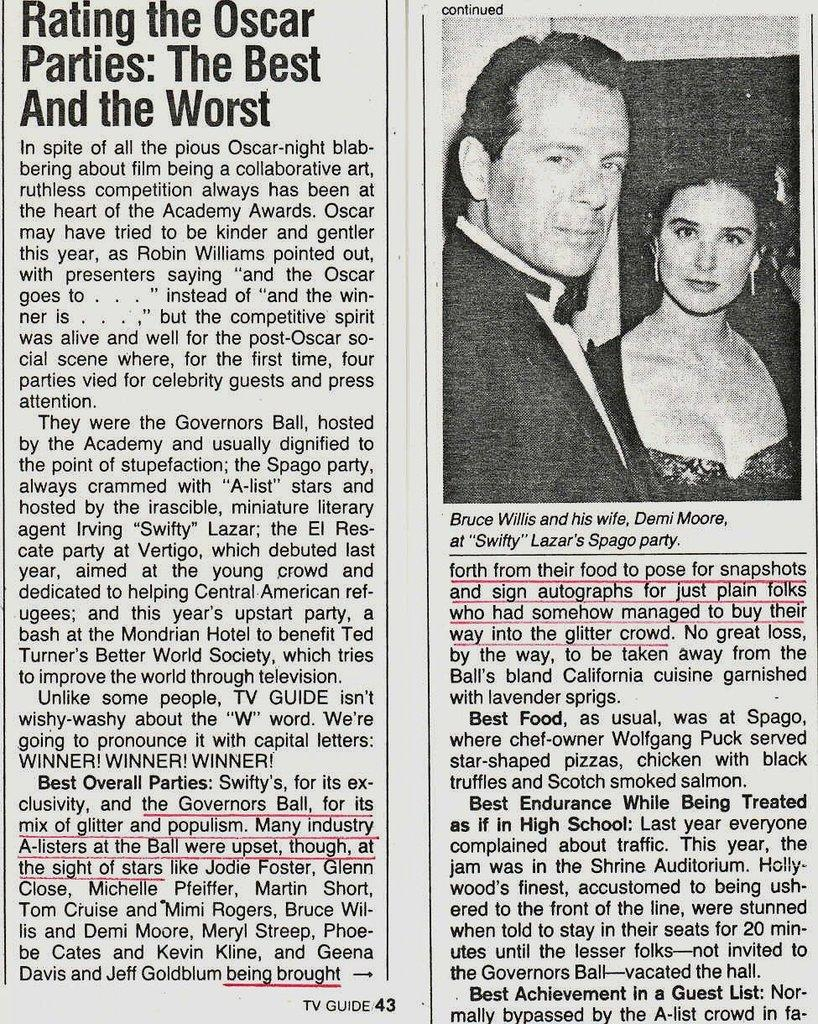What is present in the picture? There is a paper in the picture. What can be found on the paper? The paper has text on it and an image of people. What type of lumber can be seen near the seashore in the image? There is no lumber or seashore present in the image; it only features a paper with text and an image of people. 